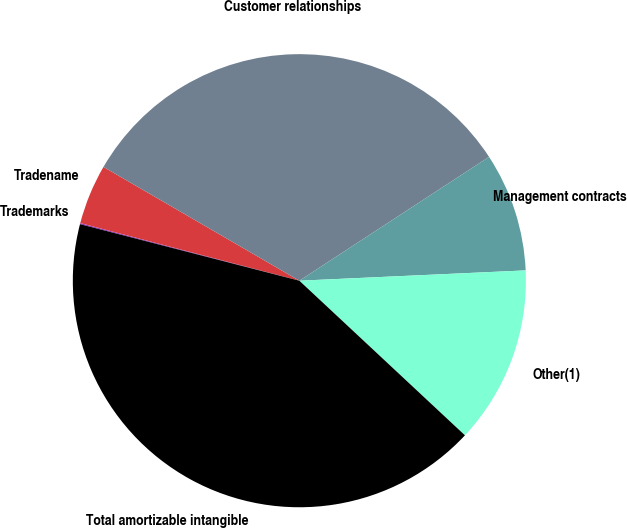Convert chart to OTSL. <chart><loc_0><loc_0><loc_500><loc_500><pie_chart><fcel>Trademarks<fcel>Tradename<fcel>Customer relationships<fcel>Management contracts<fcel>Other(1)<fcel>Total amortizable intangible<nl><fcel>0.08%<fcel>4.28%<fcel>32.42%<fcel>8.48%<fcel>12.68%<fcel>42.06%<nl></chart> 